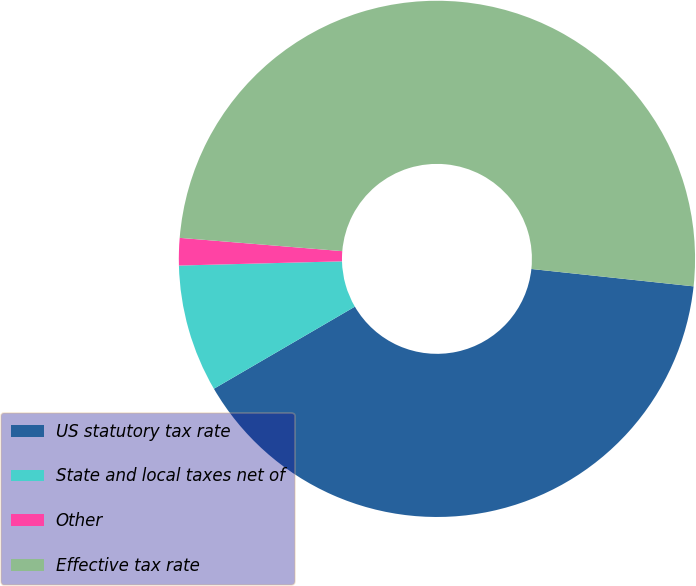<chart> <loc_0><loc_0><loc_500><loc_500><pie_chart><fcel>US statutory tax rate<fcel>State and local taxes net of<fcel>Other<fcel>Effective tax rate<nl><fcel>39.91%<fcel>7.98%<fcel>1.71%<fcel>50.4%<nl></chart> 